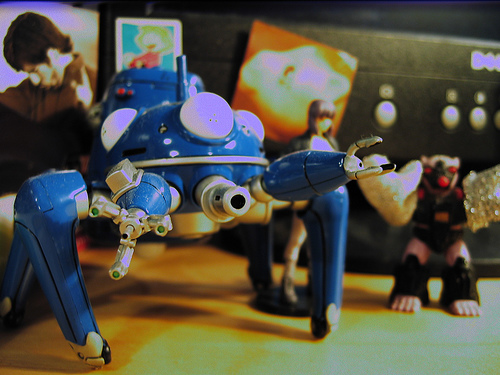<image>
Can you confirm if the robot is on the table? Yes. Looking at the image, I can see the robot is positioned on top of the table, with the table providing support. 